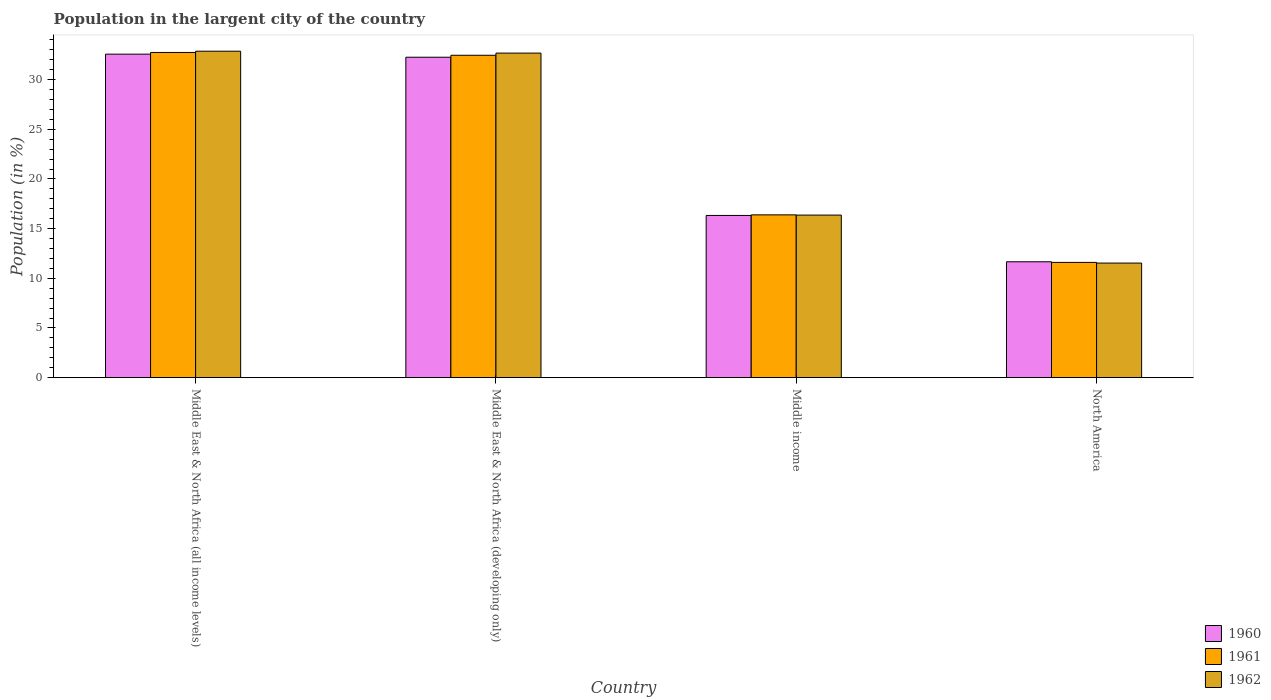How many different coloured bars are there?
Keep it short and to the point. 3. How many groups of bars are there?
Your response must be concise. 4. Are the number of bars on each tick of the X-axis equal?
Provide a succinct answer. Yes. How many bars are there on the 1st tick from the left?
Ensure brevity in your answer.  3. What is the label of the 1st group of bars from the left?
Provide a succinct answer. Middle East & North Africa (all income levels). In how many cases, is the number of bars for a given country not equal to the number of legend labels?
Your response must be concise. 0. What is the percentage of population in the largent city in 1962 in Middle income?
Offer a terse response. 16.36. Across all countries, what is the maximum percentage of population in the largent city in 1962?
Offer a very short reply. 32.86. Across all countries, what is the minimum percentage of population in the largent city in 1962?
Your response must be concise. 11.53. In which country was the percentage of population in the largent city in 1960 maximum?
Provide a succinct answer. Middle East & North Africa (all income levels). What is the total percentage of population in the largent city in 1960 in the graph?
Keep it short and to the point. 92.81. What is the difference between the percentage of population in the largent city in 1960 in Middle East & North Africa (all income levels) and that in Middle East & North Africa (developing only)?
Give a very brief answer. 0.31. What is the difference between the percentage of population in the largent city in 1961 in Middle East & North Africa (all income levels) and the percentage of population in the largent city in 1960 in North America?
Provide a short and direct response. 21.07. What is the average percentage of population in the largent city in 1960 per country?
Offer a very short reply. 23.2. What is the difference between the percentage of population in the largent city of/in 1960 and percentage of population in the largent city of/in 1961 in Middle East & North Africa (developing only)?
Offer a terse response. -0.2. In how many countries, is the percentage of population in the largent city in 1961 greater than 22 %?
Provide a short and direct response. 2. What is the ratio of the percentage of population in the largent city in 1961 in Middle East & North Africa (all income levels) to that in Middle income?
Give a very brief answer. 2. Is the difference between the percentage of population in the largent city in 1960 in Middle East & North Africa (developing only) and Middle income greater than the difference between the percentage of population in the largent city in 1961 in Middle East & North Africa (developing only) and Middle income?
Offer a very short reply. No. What is the difference between the highest and the second highest percentage of population in the largent city in 1961?
Offer a terse response. 16.35. What is the difference between the highest and the lowest percentage of population in the largent city in 1961?
Make the answer very short. 21.13. In how many countries, is the percentage of population in the largent city in 1960 greater than the average percentage of population in the largent city in 1960 taken over all countries?
Provide a succinct answer. 2. What does the 3rd bar from the right in Middle income represents?
Offer a very short reply. 1960. Is it the case that in every country, the sum of the percentage of population in the largent city in 1960 and percentage of population in the largent city in 1962 is greater than the percentage of population in the largent city in 1961?
Provide a short and direct response. Yes. How many bars are there?
Offer a very short reply. 12. Are the values on the major ticks of Y-axis written in scientific E-notation?
Make the answer very short. No. Does the graph contain grids?
Give a very brief answer. No. How many legend labels are there?
Offer a very short reply. 3. How are the legend labels stacked?
Offer a terse response. Vertical. What is the title of the graph?
Give a very brief answer. Population in the largent city of the country. Does "1963" appear as one of the legend labels in the graph?
Keep it short and to the point. No. What is the label or title of the X-axis?
Your answer should be very brief. Country. What is the Population (in %) of 1960 in Middle East & North Africa (all income levels)?
Your answer should be compact. 32.56. What is the Population (in %) in 1961 in Middle East & North Africa (all income levels)?
Your response must be concise. 32.73. What is the Population (in %) in 1962 in Middle East & North Africa (all income levels)?
Give a very brief answer. 32.86. What is the Population (in %) in 1960 in Middle East & North Africa (developing only)?
Make the answer very short. 32.25. What is the Population (in %) of 1961 in Middle East & North Africa (developing only)?
Your answer should be compact. 32.45. What is the Population (in %) of 1962 in Middle East & North Africa (developing only)?
Make the answer very short. 32.67. What is the Population (in %) of 1960 in Middle income?
Keep it short and to the point. 16.33. What is the Population (in %) in 1961 in Middle income?
Provide a succinct answer. 16.39. What is the Population (in %) in 1962 in Middle income?
Offer a very short reply. 16.36. What is the Population (in %) of 1960 in North America?
Your response must be concise. 11.67. What is the Population (in %) in 1961 in North America?
Make the answer very short. 11.6. What is the Population (in %) of 1962 in North America?
Keep it short and to the point. 11.53. Across all countries, what is the maximum Population (in %) in 1960?
Offer a very short reply. 32.56. Across all countries, what is the maximum Population (in %) in 1961?
Offer a terse response. 32.73. Across all countries, what is the maximum Population (in %) in 1962?
Provide a short and direct response. 32.86. Across all countries, what is the minimum Population (in %) in 1960?
Your answer should be very brief. 11.67. Across all countries, what is the minimum Population (in %) in 1961?
Offer a very short reply. 11.6. Across all countries, what is the minimum Population (in %) in 1962?
Your answer should be very brief. 11.53. What is the total Population (in %) in 1960 in the graph?
Keep it short and to the point. 92.81. What is the total Population (in %) in 1961 in the graph?
Make the answer very short. 93.17. What is the total Population (in %) in 1962 in the graph?
Ensure brevity in your answer.  93.43. What is the difference between the Population (in %) in 1960 in Middle East & North Africa (all income levels) and that in Middle East & North Africa (developing only)?
Your response must be concise. 0.31. What is the difference between the Population (in %) in 1961 in Middle East & North Africa (all income levels) and that in Middle East & North Africa (developing only)?
Give a very brief answer. 0.28. What is the difference between the Population (in %) in 1962 in Middle East & North Africa (all income levels) and that in Middle East & North Africa (developing only)?
Your response must be concise. 0.19. What is the difference between the Population (in %) of 1960 in Middle East & North Africa (all income levels) and that in Middle income?
Give a very brief answer. 16.24. What is the difference between the Population (in %) in 1961 in Middle East & North Africa (all income levels) and that in Middle income?
Offer a very short reply. 16.35. What is the difference between the Population (in %) of 1962 in Middle East & North Africa (all income levels) and that in Middle income?
Provide a succinct answer. 16.5. What is the difference between the Population (in %) in 1960 in Middle East & North Africa (all income levels) and that in North America?
Ensure brevity in your answer.  20.9. What is the difference between the Population (in %) in 1961 in Middle East & North Africa (all income levels) and that in North America?
Offer a very short reply. 21.13. What is the difference between the Population (in %) of 1962 in Middle East & North Africa (all income levels) and that in North America?
Offer a terse response. 21.33. What is the difference between the Population (in %) of 1960 in Middle East & North Africa (developing only) and that in Middle income?
Ensure brevity in your answer.  15.93. What is the difference between the Population (in %) of 1961 in Middle East & North Africa (developing only) and that in Middle income?
Provide a short and direct response. 16.06. What is the difference between the Population (in %) of 1962 in Middle East & North Africa (developing only) and that in Middle income?
Keep it short and to the point. 16.3. What is the difference between the Population (in %) in 1960 in Middle East & North Africa (developing only) and that in North America?
Make the answer very short. 20.59. What is the difference between the Population (in %) of 1961 in Middle East & North Africa (developing only) and that in North America?
Your answer should be very brief. 20.85. What is the difference between the Population (in %) of 1962 in Middle East & North Africa (developing only) and that in North America?
Offer a very short reply. 21.13. What is the difference between the Population (in %) in 1960 in Middle income and that in North America?
Your answer should be compact. 4.66. What is the difference between the Population (in %) in 1961 in Middle income and that in North America?
Make the answer very short. 4.78. What is the difference between the Population (in %) in 1962 in Middle income and that in North America?
Keep it short and to the point. 4.83. What is the difference between the Population (in %) in 1960 in Middle East & North Africa (all income levels) and the Population (in %) in 1961 in Middle East & North Africa (developing only)?
Keep it short and to the point. 0.11. What is the difference between the Population (in %) of 1960 in Middle East & North Africa (all income levels) and the Population (in %) of 1962 in Middle East & North Africa (developing only)?
Your answer should be very brief. -0.1. What is the difference between the Population (in %) in 1961 in Middle East & North Africa (all income levels) and the Population (in %) in 1962 in Middle East & North Africa (developing only)?
Your answer should be compact. 0.06. What is the difference between the Population (in %) of 1960 in Middle East & North Africa (all income levels) and the Population (in %) of 1961 in Middle income?
Provide a succinct answer. 16.18. What is the difference between the Population (in %) of 1960 in Middle East & North Africa (all income levels) and the Population (in %) of 1962 in Middle income?
Make the answer very short. 16.2. What is the difference between the Population (in %) in 1961 in Middle East & North Africa (all income levels) and the Population (in %) in 1962 in Middle income?
Offer a very short reply. 16.37. What is the difference between the Population (in %) in 1960 in Middle East & North Africa (all income levels) and the Population (in %) in 1961 in North America?
Your answer should be compact. 20.96. What is the difference between the Population (in %) in 1960 in Middle East & North Africa (all income levels) and the Population (in %) in 1962 in North America?
Keep it short and to the point. 21.03. What is the difference between the Population (in %) in 1961 in Middle East & North Africa (all income levels) and the Population (in %) in 1962 in North America?
Make the answer very short. 21.2. What is the difference between the Population (in %) of 1960 in Middle East & North Africa (developing only) and the Population (in %) of 1961 in Middle income?
Provide a short and direct response. 15.87. What is the difference between the Population (in %) of 1960 in Middle East & North Africa (developing only) and the Population (in %) of 1962 in Middle income?
Your response must be concise. 15.89. What is the difference between the Population (in %) in 1961 in Middle East & North Africa (developing only) and the Population (in %) in 1962 in Middle income?
Provide a succinct answer. 16.08. What is the difference between the Population (in %) of 1960 in Middle East & North Africa (developing only) and the Population (in %) of 1961 in North America?
Keep it short and to the point. 20.65. What is the difference between the Population (in %) of 1960 in Middle East & North Africa (developing only) and the Population (in %) of 1962 in North America?
Ensure brevity in your answer.  20.72. What is the difference between the Population (in %) in 1961 in Middle East & North Africa (developing only) and the Population (in %) in 1962 in North America?
Provide a short and direct response. 20.91. What is the difference between the Population (in %) in 1960 in Middle income and the Population (in %) in 1961 in North America?
Give a very brief answer. 4.73. What is the difference between the Population (in %) in 1960 in Middle income and the Population (in %) in 1962 in North America?
Provide a short and direct response. 4.79. What is the difference between the Population (in %) in 1961 in Middle income and the Population (in %) in 1962 in North America?
Your answer should be very brief. 4.85. What is the average Population (in %) in 1960 per country?
Provide a succinct answer. 23.2. What is the average Population (in %) of 1961 per country?
Keep it short and to the point. 23.29. What is the average Population (in %) of 1962 per country?
Give a very brief answer. 23.36. What is the difference between the Population (in %) in 1960 and Population (in %) in 1961 in Middle East & North Africa (all income levels)?
Offer a terse response. -0.17. What is the difference between the Population (in %) in 1960 and Population (in %) in 1962 in Middle East & North Africa (all income levels)?
Provide a succinct answer. -0.3. What is the difference between the Population (in %) of 1961 and Population (in %) of 1962 in Middle East & North Africa (all income levels)?
Your answer should be very brief. -0.13. What is the difference between the Population (in %) in 1960 and Population (in %) in 1961 in Middle East & North Africa (developing only)?
Your answer should be compact. -0.2. What is the difference between the Population (in %) of 1960 and Population (in %) of 1962 in Middle East & North Africa (developing only)?
Your answer should be compact. -0.41. What is the difference between the Population (in %) of 1961 and Population (in %) of 1962 in Middle East & North Africa (developing only)?
Offer a very short reply. -0.22. What is the difference between the Population (in %) of 1960 and Population (in %) of 1961 in Middle income?
Give a very brief answer. -0.06. What is the difference between the Population (in %) of 1960 and Population (in %) of 1962 in Middle income?
Your response must be concise. -0.04. What is the difference between the Population (in %) of 1961 and Population (in %) of 1962 in Middle income?
Keep it short and to the point. 0.02. What is the difference between the Population (in %) of 1960 and Population (in %) of 1961 in North America?
Offer a terse response. 0.06. What is the difference between the Population (in %) in 1960 and Population (in %) in 1962 in North America?
Your answer should be very brief. 0.13. What is the difference between the Population (in %) of 1961 and Population (in %) of 1962 in North America?
Offer a terse response. 0.07. What is the ratio of the Population (in %) in 1960 in Middle East & North Africa (all income levels) to that in Middle East & North Africa (developing only)?
Your response must be concise. 1.01. What is the ratio of the Population (in %) in 1961 in Middle East & North Africa (all income levels) to that in Middle East & North Africa (developing only)?
Give a very brief answer. 1.01. What is the ratio of the Population (in %) of 1962 in Middle East & North Africa (all income levels) to that in Middle East & North Africa (developing only)?
Provide a succinct answer. 1.01. What is the ratio of the Population (in %) of 1960 in Middle East & North Africa (all income levels) to that in Middle income?
Make the answer very short. 1.99. What is the ratio of the Population (in %) in 1961 in Middle East & North Africa (all income levels) to that in Middle income?
Ensure brevity in your answer.  2. What is the ratio of the Population (in %) in 1962 in Middle East & North Africa (all income levels) to that in Middle income?
Provide a short and direct response. 2.01. What is the ratio of the Population (in %) of 1960 in Middle East & North Africa (all income levels) to that in North America?
Your answer should be compact. 2.79. What is the ratio of the Population (in %) of 1961 in Middle East & North Africa (all income levels) to that in North America?
Your response must be concise. 2.82. What is the ratio of the Population (in %) of 1962 in Middle East & North Africa (all income levels) to that in North America?
Keep it short and to the point. 2.85. What is the ratio of the Population (in %) of 1960 in Middle East & North Africa (developing only) to that in Middle income?
Keep it short and to the point. 1.98. What is the ratio of the Population (in %) in 1961 in Middle East & North Africa (developing only) to that in Middle income?
Provide a succinct answer. 1.98. What is the ratio of the Population (in %) of 1962 in Middle East & North Africa (developing only) to that in Middle income?
Provide a succinct answer. 2. What is the ratio of the Population (in %) of 1960 in Middle East & North Africa (developing only) to that in North America?
Your answer should be compact. 2.76. What is the ratio of the Population (in %) of 1961 in Middle East & North Africa (developing only) to that in North America?
Your answer should be very brief. 2.8. What is the ratio of the Population (in %) in 1962 in Middle East & North Africa (developing only) to that in North America?
Your response must be concise. 2.83. What is the ratio of the Population (in %) of 1960 in Middle income to that in North America?
Keep it short and to the point. 1.4. What is the ratio of the Population (in %) of 1961 in Middle income to that in North America?
Offer a very short reply. 1.41. What is the ratio of the Population (in %) of 1962 in Middle income to that in North America?
Ensure brevity in your answer.  1.42. What is the difference between the highest and the second highest Population (in %) of 1960?
Offer a terse response. 0.31. What is the difference between the highest and the second highest Population (in %) of 1961?
Your answer should be very brief. 0.28. What is the difference between the highest and the second highest Population (in %) of 1962?
Give a very brief answer. 0.19. What is the difference between the highest and the lowest Population (in %) in 1960?
Offer a very short reply. 20.9. What is the difference between the highest and the lowest Population (in %) in 1961?
Your answer should be very brief. 21.13. What is the difference between the highest and the lowest Population (in %) of 1962?
Your answer should be very brief. 21.33. 